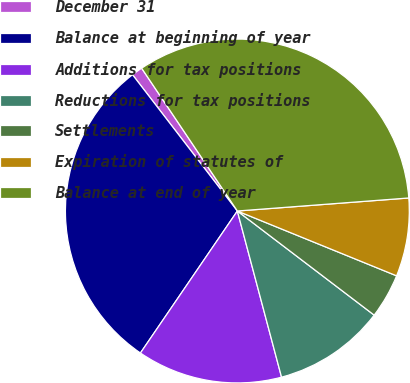Convert chart to OTSL. <chart><loc_0><loc_0><loc_500><loc_500><pie_chart><fcel>December 31<fcel>Balance at beginning of year<fcel>Additions for tax positions<fcel>Reductions for tax positions<fcel>Settlements<fcel>Expiration of statutes of<fcel>Balance at end of year<nl><fcel>1.04%<fcel>30.03%<fcel>13.67%<fcel>10.51%<fcel>4.2%<fcel>7.36%<fcel>33.19%<nl></chart> 